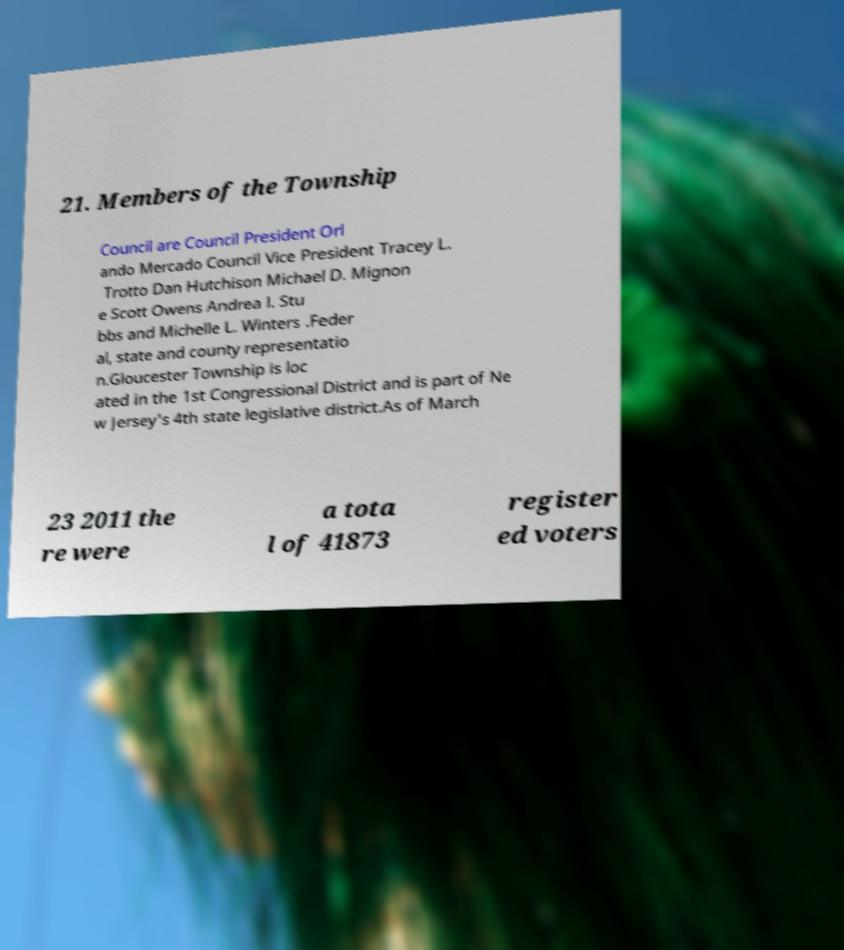What messages or text are displayed in this image? I need them in a readable, typed format. 21. Members of the Township Council are Council President Orl ando Mercado Council Vice President Tracey L. Trotto Dan Hutchison Michael D. Mignon e Scott Owens Andrea l. Stu bbs and Michelle L. Winters .Feder al, state and county representatio n.Gloucester Township is loc ated in the 1st Congressional District and is part of Ne w Jersey's 4th state legislative district.As of March 23 2011 the re were a tota l of 41873 register ed voters 